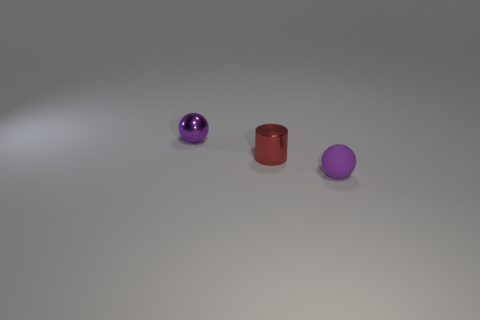Is there anything else that is the same shape as the tiny red shiny thing?
Give a very brief answer. No. Are there the same number of spheres that are in front of the small purple rubber sphere and green things?
Ensure brevity in your answer.  Yes. Are there any tiny spheres that are in front of the red cylinder that is left of the rubber sphere in front of the shiny ball?
Make the answer very short. Yes. What is the color of the ball that is made of the same material as the tiny cylinder?
Give a very brief answer. Purple. There is a ball behind the rubber object; is it the same color as the small shiny cylinder?
Your response must be concise. No. How many blocks are tiny shiny things or tiny red metallic things?
Ensure brevity in your answer.  0. There is a purple thing in front of the small purple thing that is behind the tiny purple object that is in front of the tiny purple metallic sphere; what size is it?
Your response must be concise. Small. The purple rubber object that is the same size as the red metallic object is what shape?
Your answer should be very brief. Sphere. The purple shiny thing has what shape?
Your answer should be compact. Sphere. Is the purple ball that is left of the red cylinder made of the same material as the tiny cylinder?
Make the answer very short. Yes. 